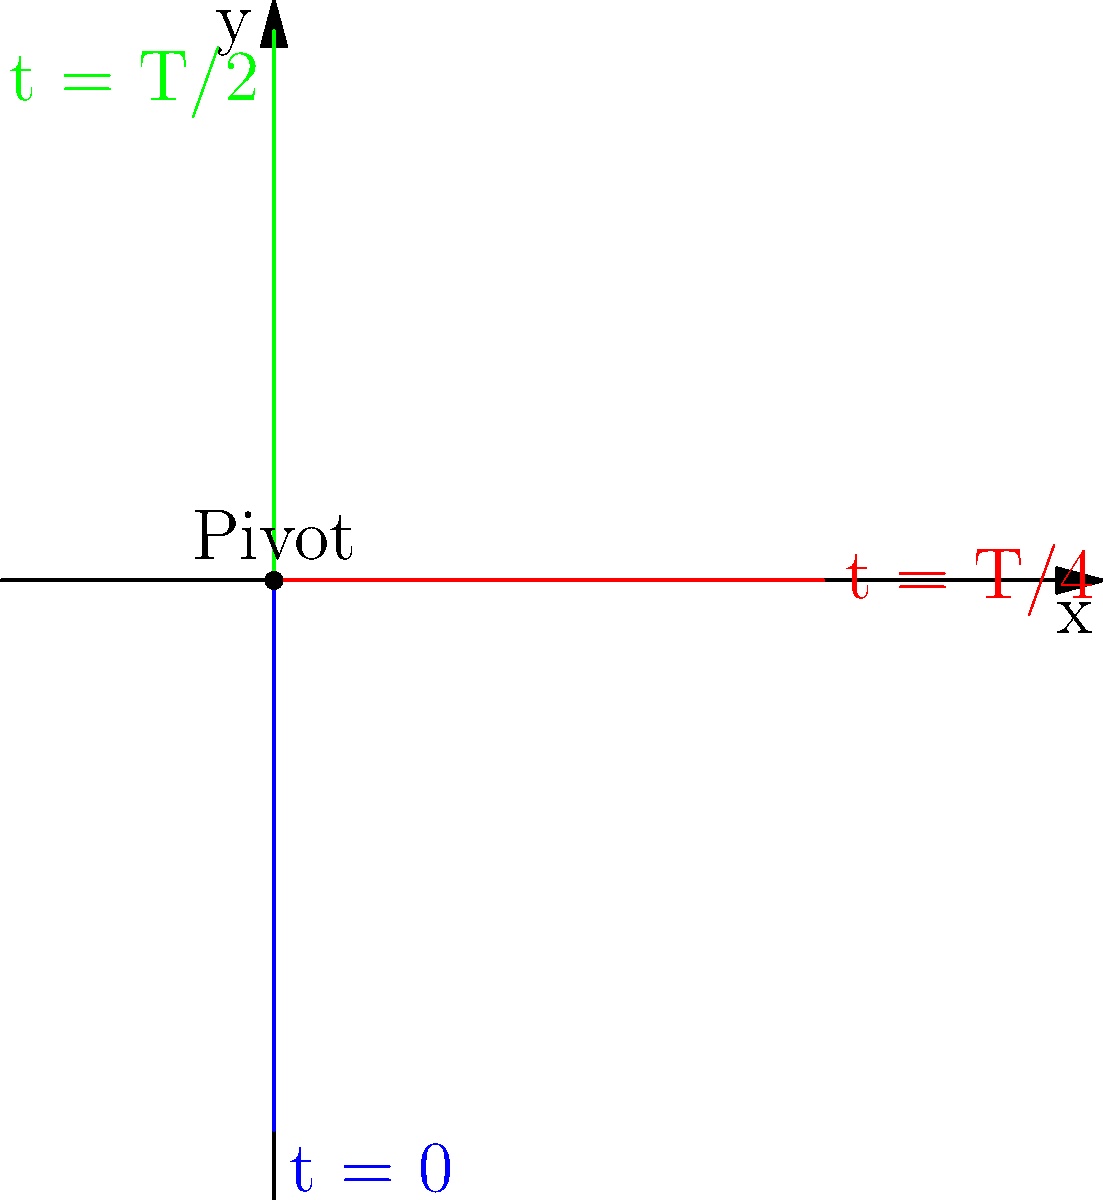In a scene for your upcoming sci-fi film, you want to create a realistic CGI animation of a simple pendulum. The pendulum has a length of 1 meter and a period of 2 seconds. If the pendulum starts at its maximum displacement, what is its angular frequency $\omega$ in radians per second, and what will be its position after 0.5 seconds? To solve this problem, let's break it down step-by-step:

1. First, we need to calculate the angular frequency $\omega$:
   The period $T$ is given as 2 seconds.
   Angular frequency is related to the period by the formula: $\omega = \frac{2\pi}{T}$
   
   Therefore, $\omega = \frac{2\pi}{2} = \pi$ rad/s

2. Now, to find the position after 0.5 seconds, we need to use the equation for simple harmonic motion:
   $x(t) = A \cos(\omega t + \phi)$
   
   Where:
   $A$ is the amplitude (maximum displacement)
   $\omega$ is the angular frequency we just calculated
   $t$ is the time (0.5 seconds in this case)
   $\phi$ is the initial phase (0 in this case, as the pendulum starts at maximum displacement)

3. Given that the length of the pendulum is 1 meter, this is also our amplitude $A$.

4. Plugging in the values:
   $x(0.5) = 1 \cdot \cos(\pi \cdot 0.5 + 0)$
   
   $x(0.5) = \cos(\frac{\pi}{2}) = 0$

5. This means that after 0.5 seconds, the pendulum will be at the equilibrium position (x = 0).

6. To fully describe the position, we also need the y-coordinate:
   $y(0.5) = -1 \cdot \sin(\pi \cdot 0.5 + 0) = -1$

Therefore, after 0.5 seconds, the position of the pendulum bob will be (0, -1) relative to the pivot point.
Answer: $\omega = \pi$ rad/s; Position at t = 0.5s: (0, -1) m 